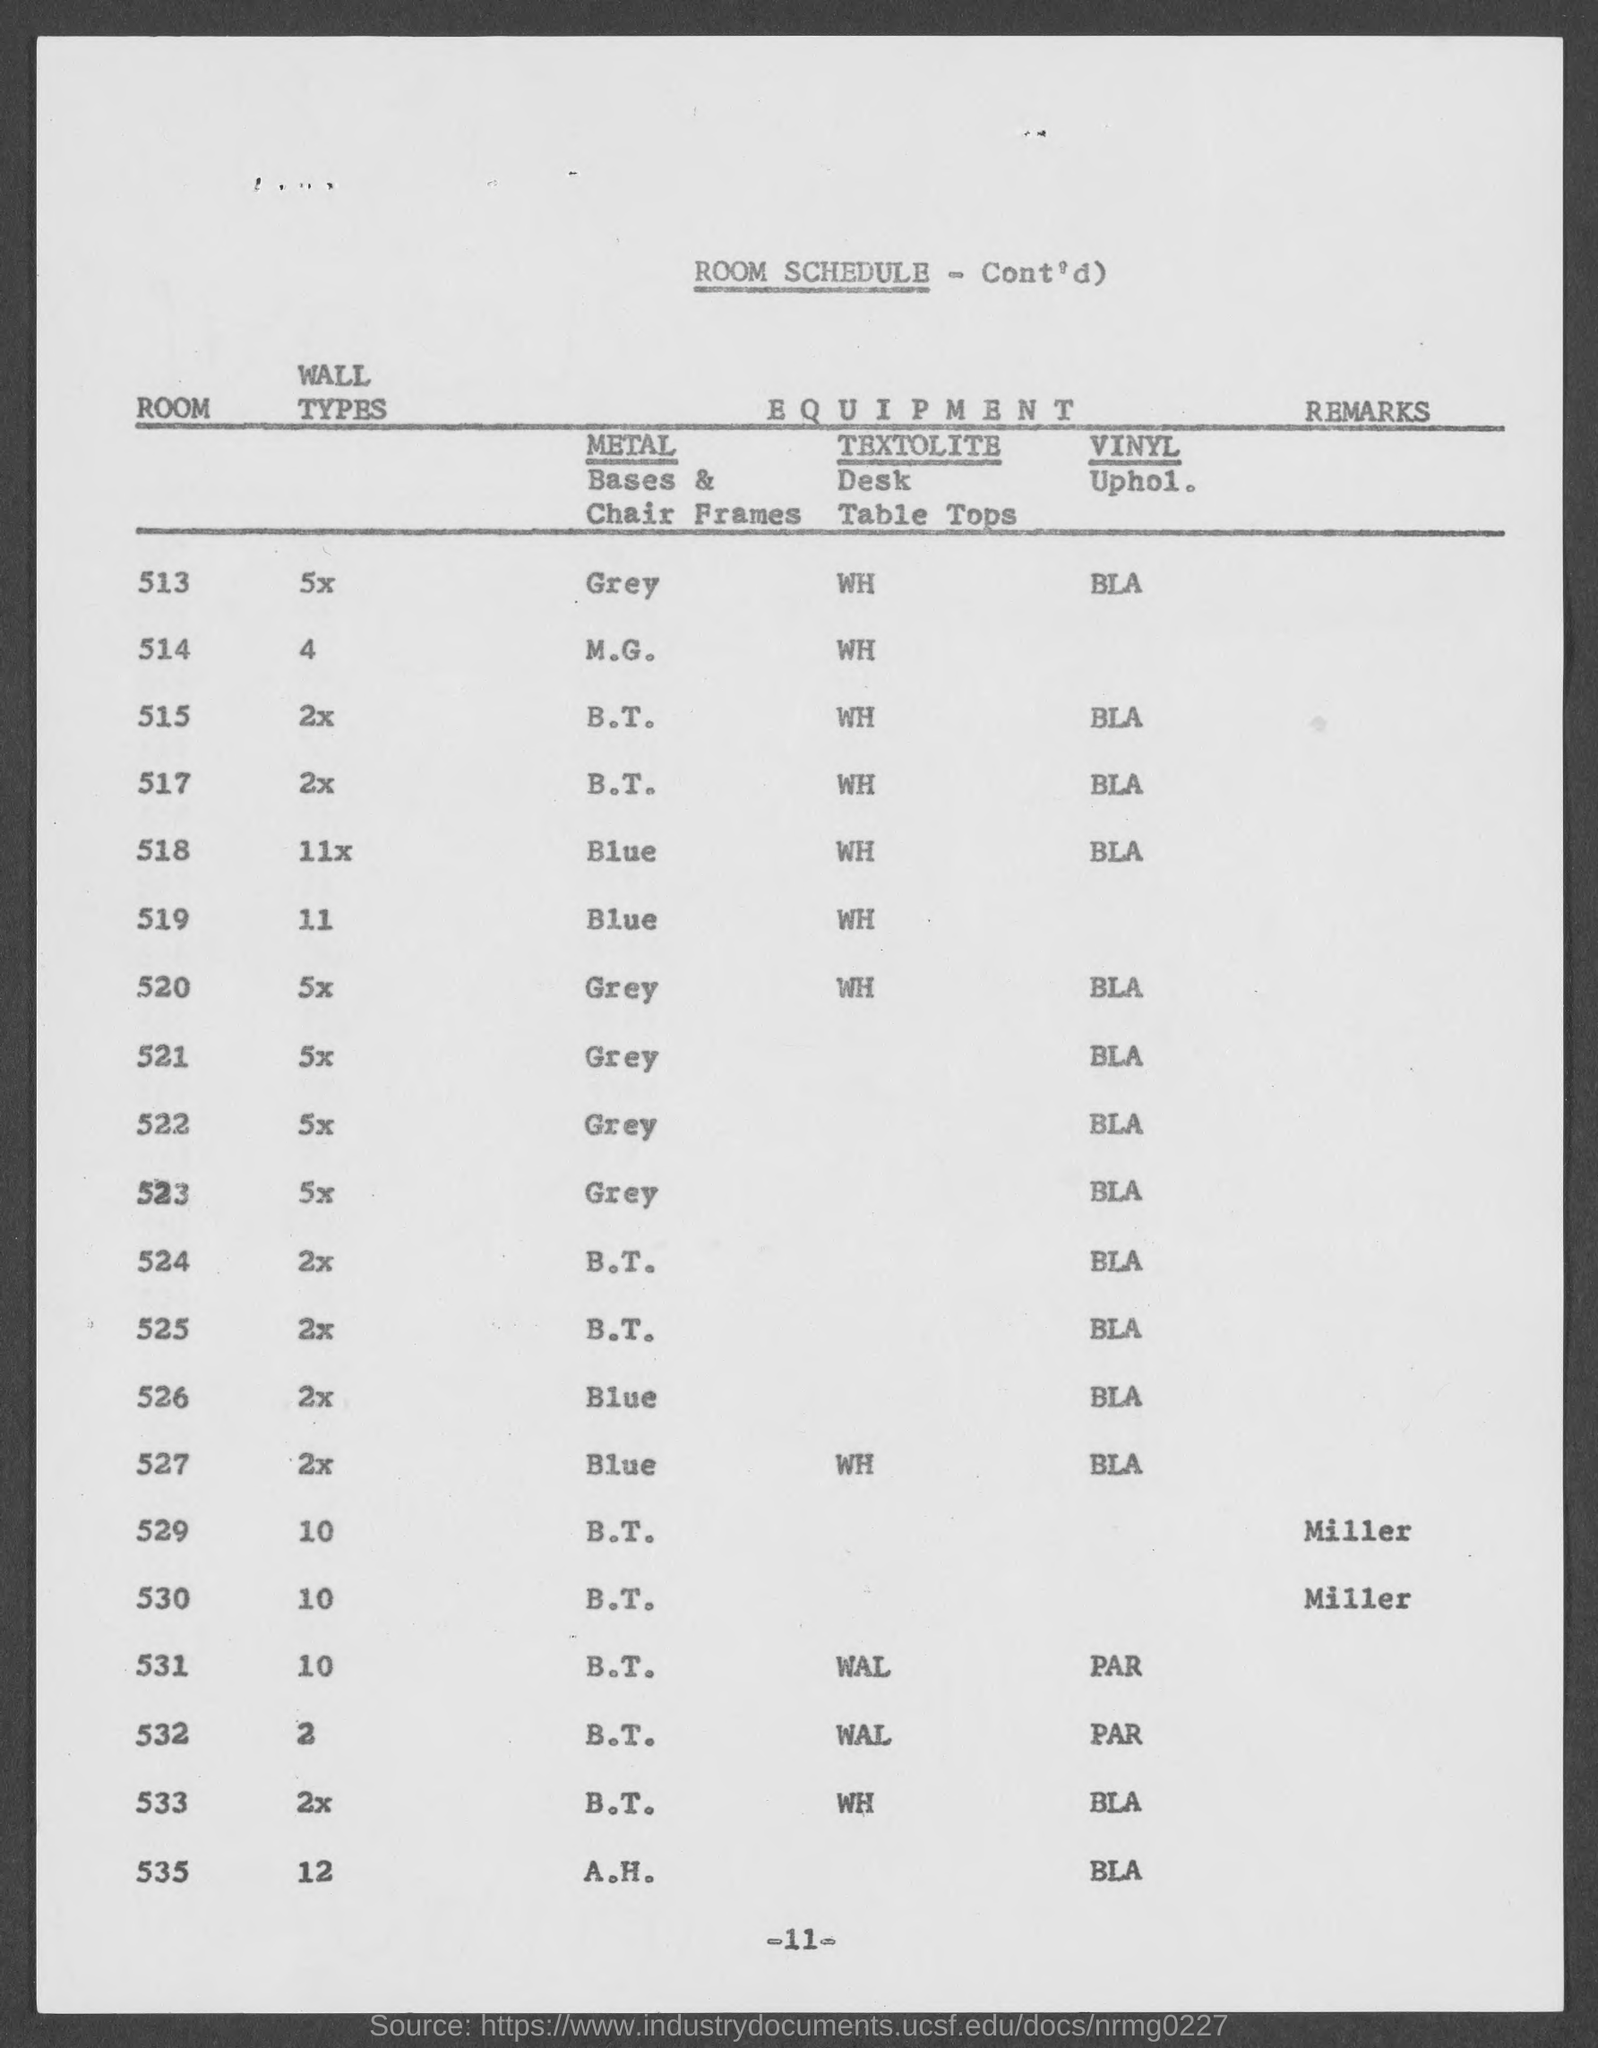What is this document about?
Ensure brevity in your answer.  Room schedule. Who has given the remarks?
Provide a succinct answer. Miller. 